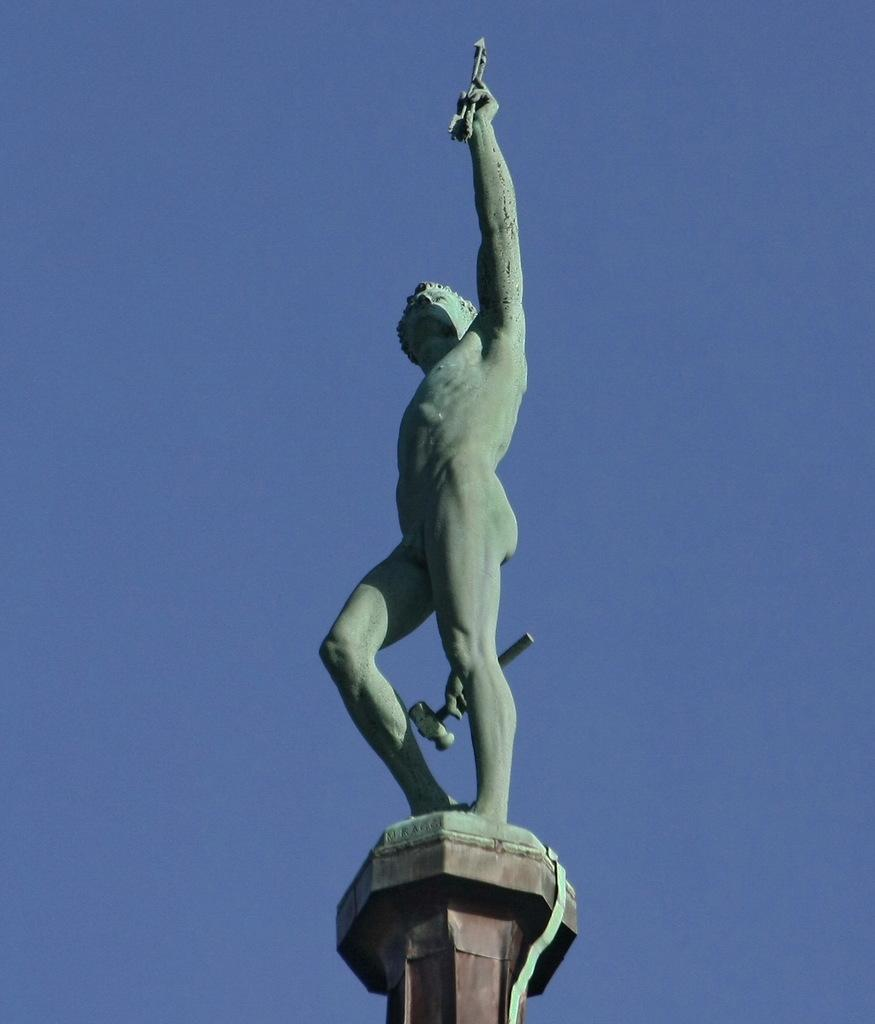What is the main subject of the image? There is a statue in the image. Where is the statue located in relation to the image? The statue is at the bottom of the image. What can be seen in the background of the image? The sky is visible in the background of the image. What type of song is being played by the statue in the image? There is no indication in the image that the statue is playing a song, as statues are typically not capable of producing sound. 